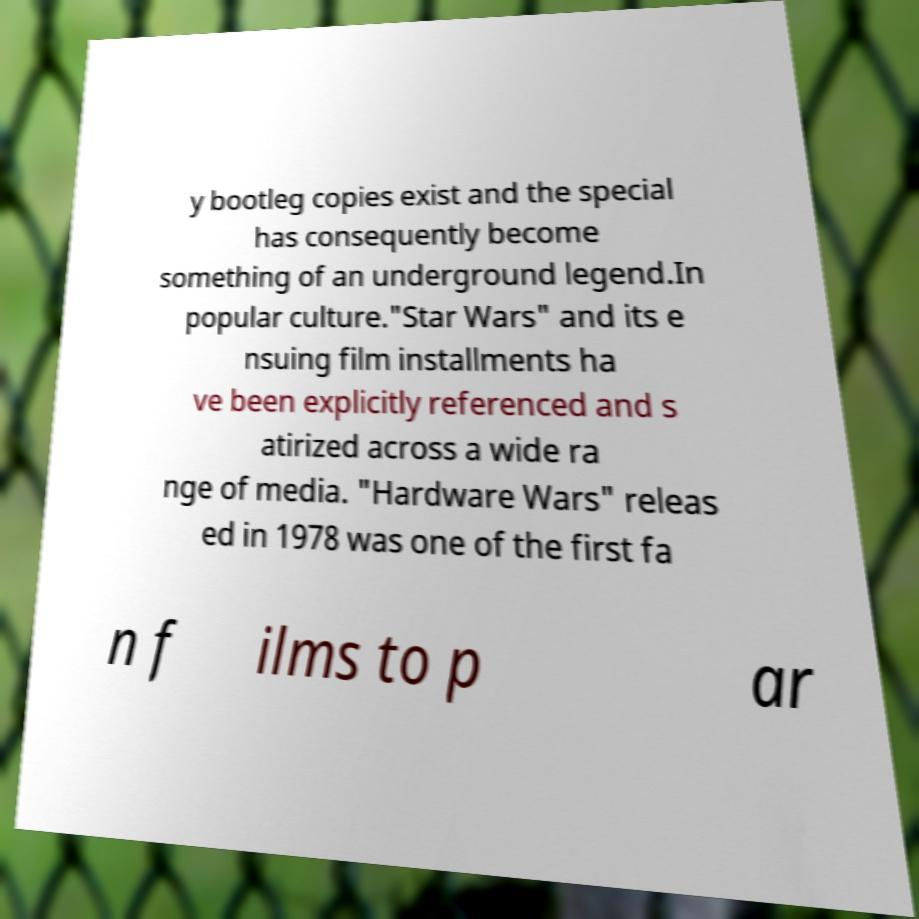I need the written content from this picture converted into text. Can you do that? y bootleg copies exist and the special has consequently become something of an underground legend.In popular culture."Star Wars" and its e nsuing film installments ha ve been explicitly referenced and s atirized across a wide ra nge of media. "Hardware Wars" releas ed in 1978 was one of the first fa n f ilms to p ar 